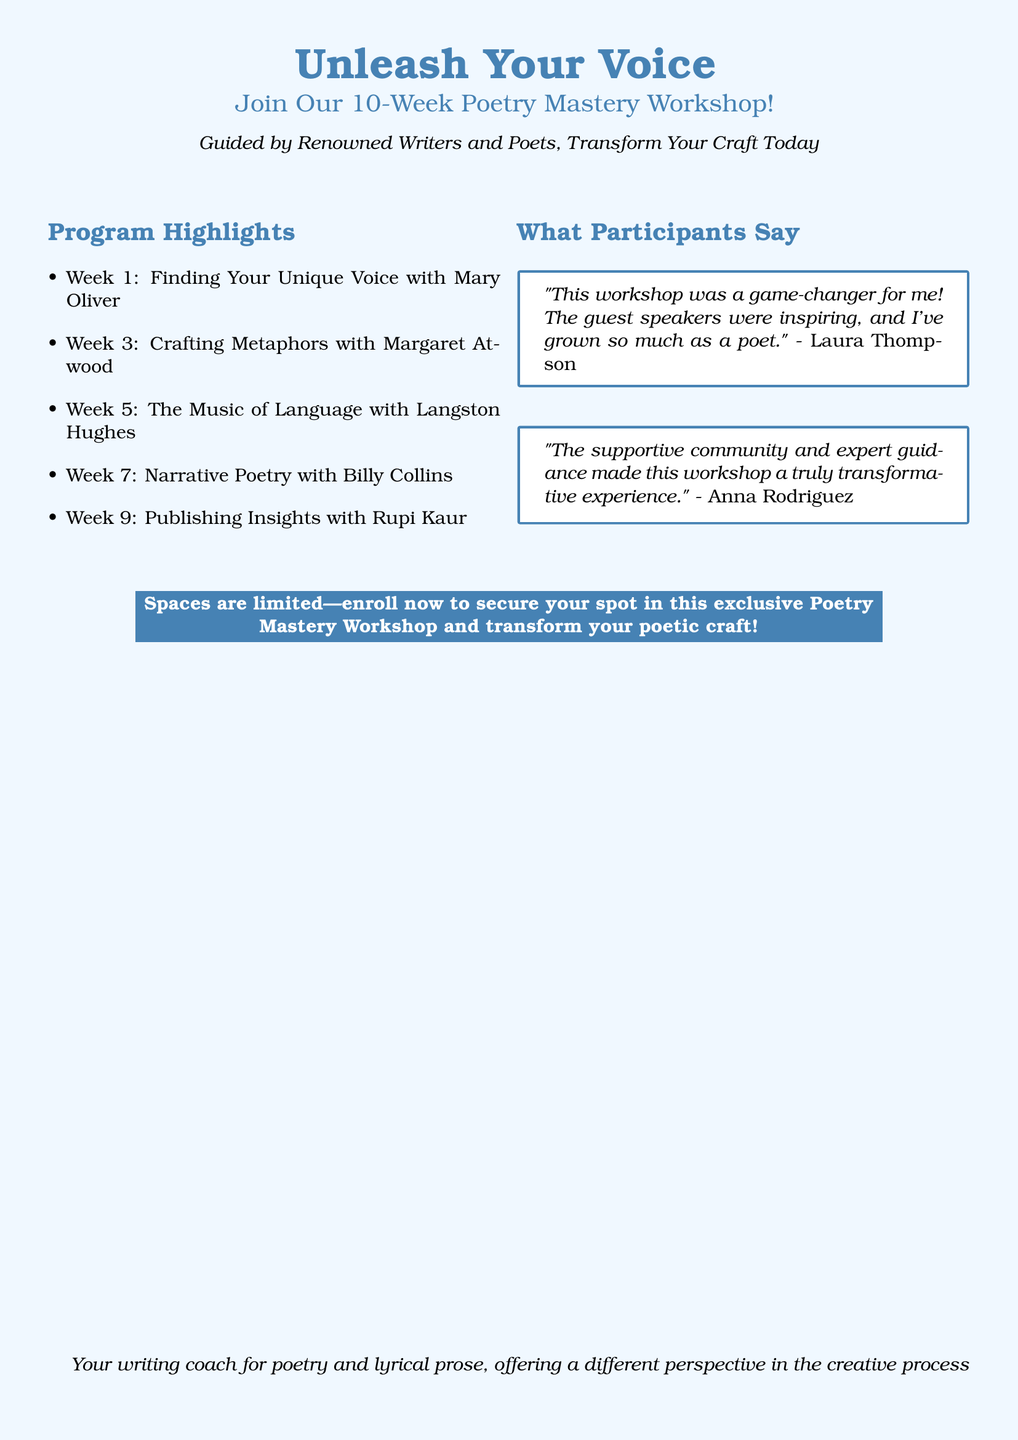What is the duration of the workshop? The duration is specifically mentioned in the title, which states it is a 10-week workshop.
Answer: 10 weeks Who is the guest speaker for Week 1? The document lists various guest speakers for each week, specifying Mary Oliver for Week 1.
Answer: Mary Oliver What is a key focus for Week 5? The highlight for Week 5 focuses on the aspect of language, particularly its musicality as presented by Langston Hughes.
Answer: The Music of Language How did Laura Thompson describe the workshop? Laura Thompson's testimonial provides insight into her perception of the experience, calling it a game-changer.
Answer: Game-changer What type of community does Anna Rodriguez mention? Anna Rodriguez's feedback highlights the nature of the community experienced during the workshop, describing it as supportive.
Answer: Supportive community How many guest speakers are mentioned in the program? A count of the guest speakers listed in the program reveals a total of five different speakers for the weeks specified.
Answer: 5 What is the call to action at the end of the document? The closing statement in a highlighted box prompts readers to take immediate action regarding enrollment in the workshop.
Answer: Enroll now Who should potential participants contact for more information? The footer indicates the role of the document's creator, who serves as a writing coach, implying they could be contacted for additional details.
Answer: Your writing coach 